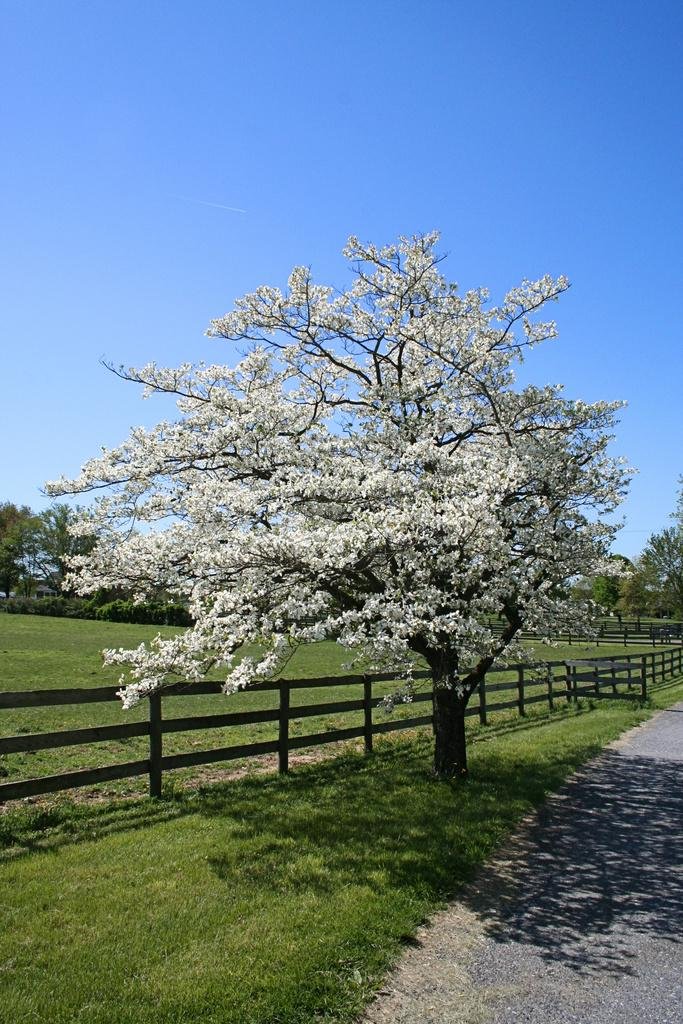What type of vegetation can be seen in the image? There is a tree and grass in the image. What structures are present in the image? There is a fence and a road in the image. What part of the natural environment is visible in the image? The sky is visible in the image. What type of toy can be seen in the throat of the person in the image? There is no person or toy present in the image, and therefore no such activity can be observed. 